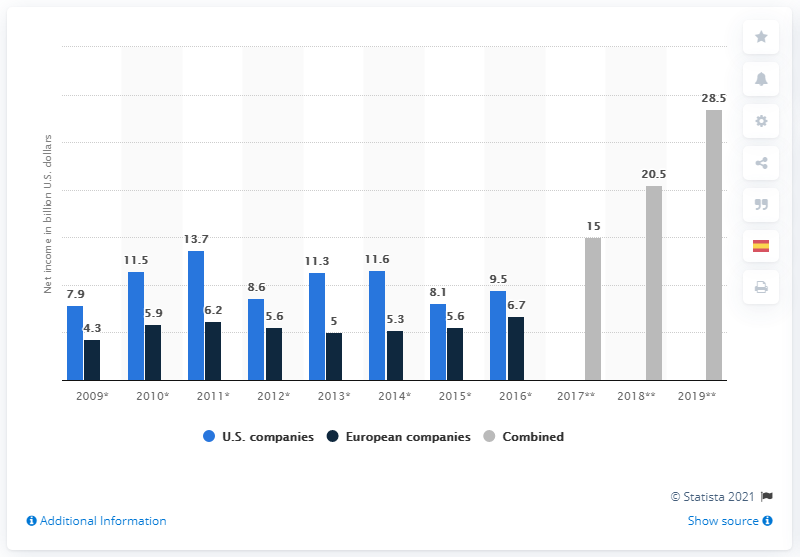Can you tell me how the net income of European companies in 2009 compares to that of US companies? Certainly! In 2009, European companies had a net income of approximately $4.3 billion, while US companies had a significantly higher net income of about $7.9 billion, as depicted in the chart. What about the growth trends for European companies from 2009 to 2013? From 2009 to 2013, European companies saw an overall increase in net income. Starting with $4.3 billion in 2009, there was an upward trend reaching $6.2 billion in 2011, a slight dip to $5.6 billion in 2012, and then rising again to $5 in 2013. 